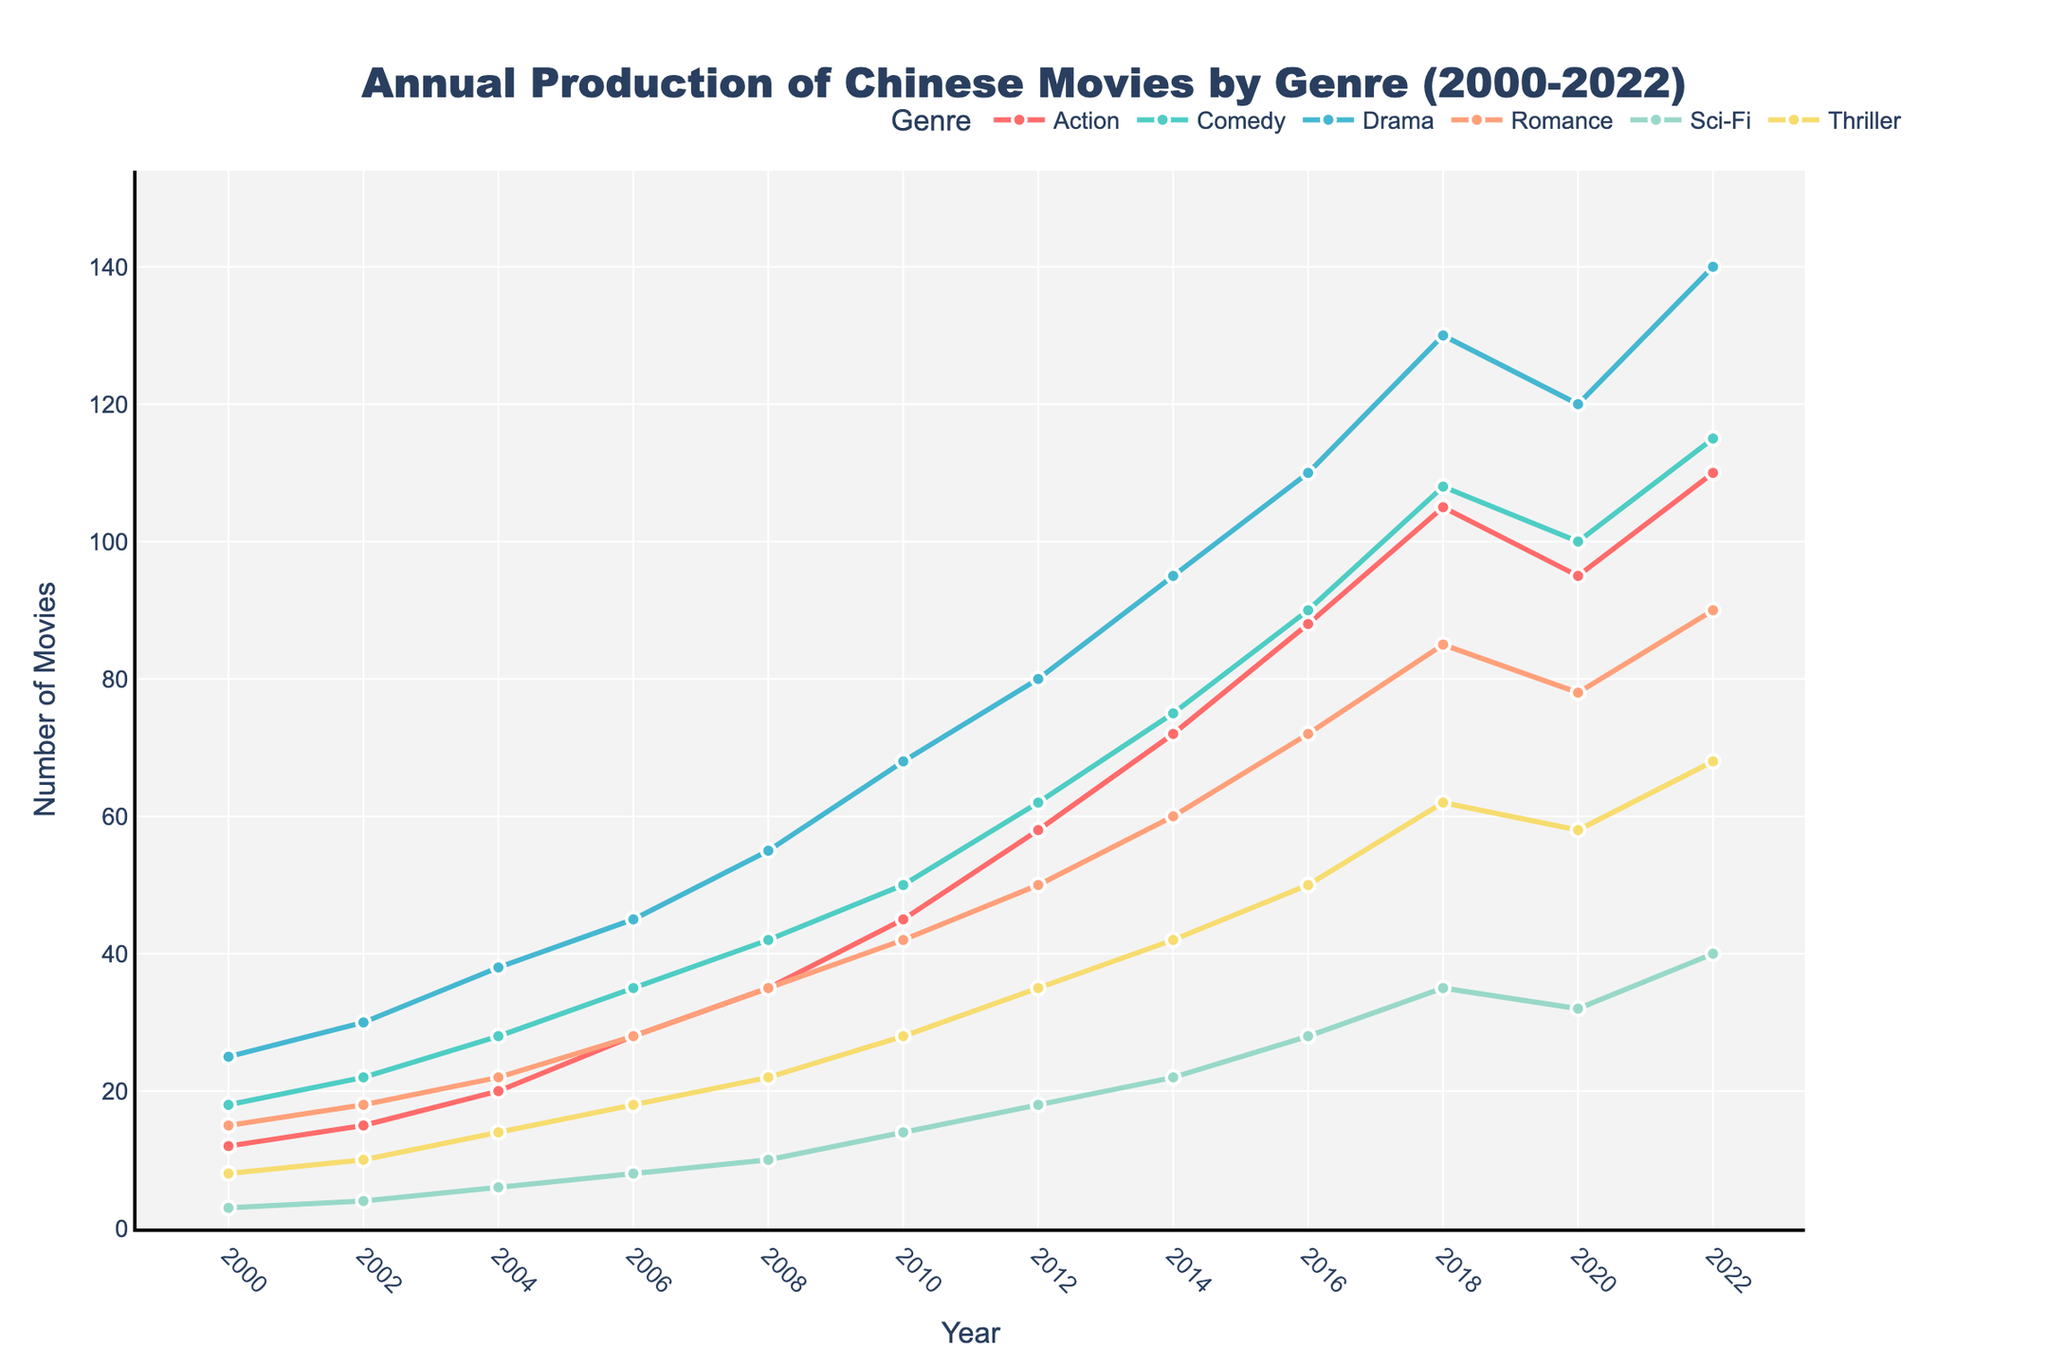Which genre had the highest production volume in 2022? Observing the highest point in 2022, we see that the Drama genre peaks the highest compared to other genres.
Answer: Drama How has the production of Sci-Fi movies changed from 2010 to 2022? In 2010, the number of Sci-Fi movies was 14. By 2022, this number had increased to 40. The change is calculated as 40 - 14.
Answer: Increased by 26 Which genre saw the steadiest increase in production from 2000 to 2022? By examining the slopes of the lines for each genre, Comedy shows a consistent and steady increase in production over the years without any dips.
Answer: Comedy What is the total number of Romance films produced from 2000 to 2010? Summing the numbers in the Romance column from 2000 to 2010 gives 15 + 18 + 22 + 28 + 35 + 42 = 160.
Answer: 160 In which year did Action movies first exceed 80 productions? Observing the Action line on the chart, it first exceeds 80 in 2016.
Answer: 2016 Which genre had the least production in 2006, and what was the volume? Among all genres in 2006, Sci-Fi had the least production with a volume of 8 movies.
Answer: Sci-Fi, 8 Compare the production volumes of Comedy and Thriller movies in 2020. Which one had more, and by how many movies? In 2020, Comedy produced 100 movies and Thriller 58. The difference is 100 - 58.
Answer: Comedy, 42 more What is the average number of Drama films produced from 2008 to 2018? Summing Drama numbers from 2008 to 2018 gives 55 + 68 + 80 + 95 + 110 + 130 = 538. Dividing by 6 (years) results in an average of 538/6 ≈ 89.67.
Answer: Approximately 89.67 Which color corresponds to the lowest number of Thriller films produced, and in which year did it occur? The smallest value for Thrillers is 8 in 2000, and the color representing Thriller is purple (but use the assigned color in the plot such as #F7DC6F if identified).
Answer: Purple, 2000 What is the overall trend in the production of Romance films from 2000 to 2022? By looking at the Romance line, there is a steady increase in production over the years from 15 in 2000 to 90 in 2022.
Answer: Steady increase 